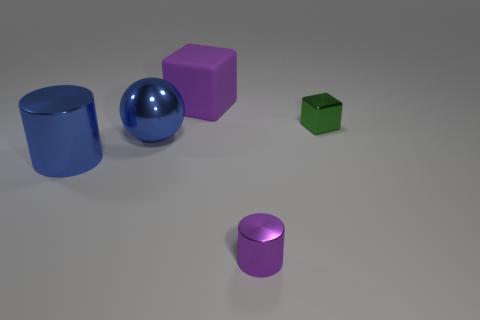Add 1 purple rubber cubes. How many objects exist? 6 Subtract 1 spheres. How many spheres are left? 0 Subtract all green blocks. How many blocks are left? 1 Subtract 0 gray spheres. How many objects are left? 5 Subtract all blocks. How many objects are left? 3 Subtract all brown spheres. Subtract all gray cylinders. How many spheres are left? 1 Subtract all gray cylinders. How many purple cubes are left? 1 Subtract all rubber blocks. Subtract all large shiny cylinders. How many objects are left? 3 Add 1 green objects. How many green objects are left? 2 Add 5 purple shiny objects. How many purple shiny objects exist? 6 